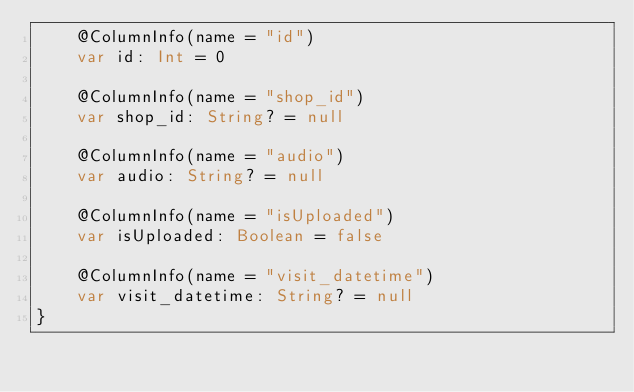Convert code to text. <code><loc_0><loc_0><loc_500><loc_500><_Kotlin_>    @ColumnInfo(name = "id")
    var id: Int = 0

    @ColumnInfo(name = "shop_id")
    var shop_id: String? = null

    @ColumnInfo(name = "audio")
    var audio: String? = null

    @ColumnInfo(name = "isUploaded")
    var isUploaded: Boolean = false

    @ColumnInfo(name = "visit_datetime")
    var visit_datetime: String? = null
}</code> 